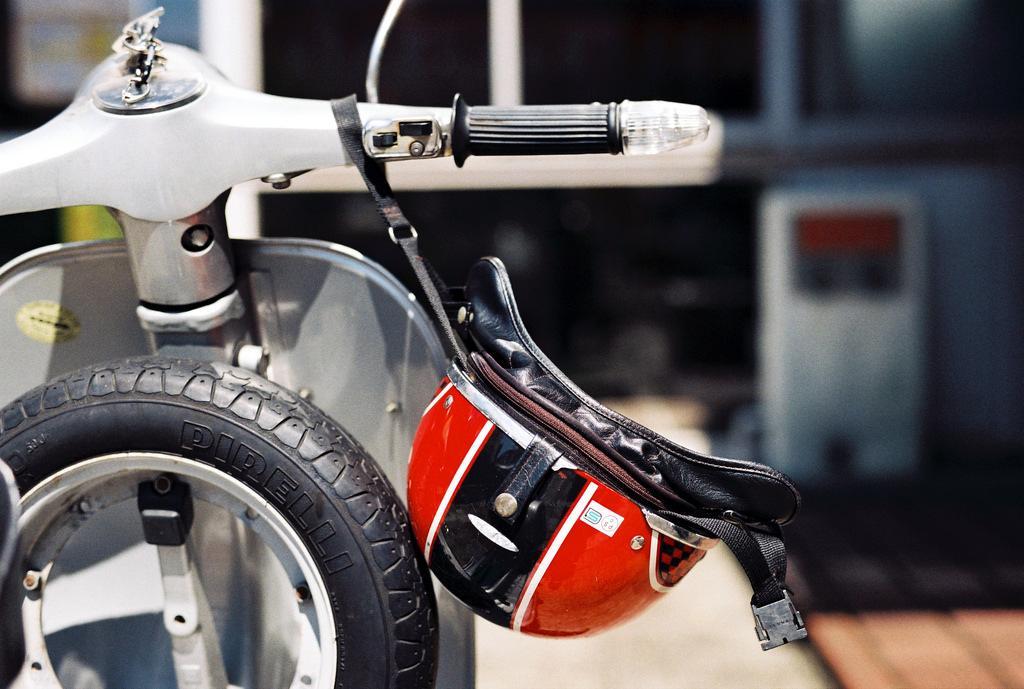Can you describe this image briefly? In this image, we can see a scooter, tyre and helmet. In the background, image is blurred. 